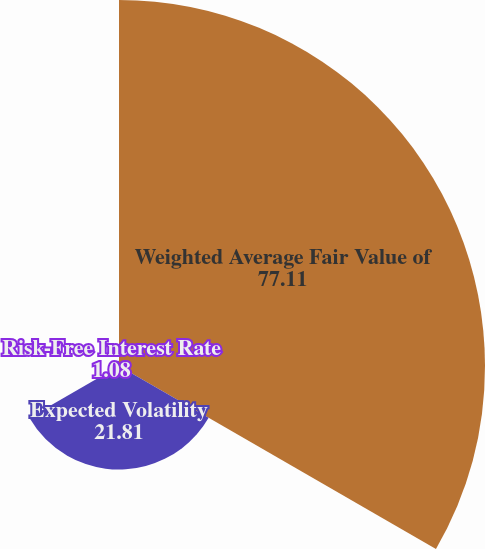<chart> <loc_0><loc_0><loc_500><loc_500><pie_chart><fcel>Weighted Average Fair Value of<fcel>Expected Volatility<fcel>Risk-Free Interest Rate<nl><fcel>77.11%<fcel>21.81%<fcel>1.08%<nl></chart> 